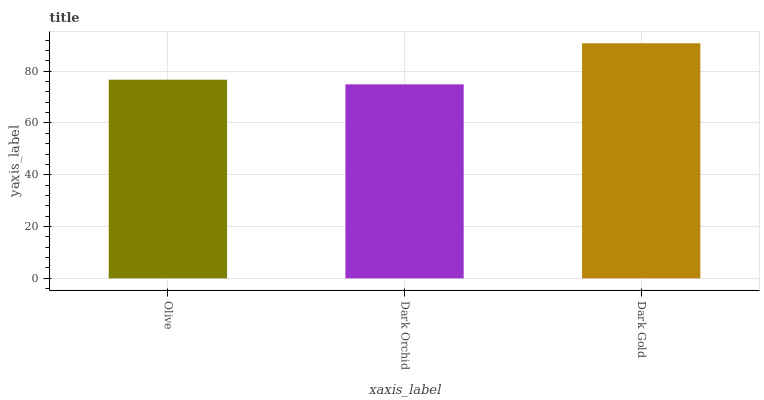Is Dark Orchid the minimum?
Answer yes or no. Yes. Is Dark Gold the maximum?
Answer yes or no. Yes. Is Dark Gold the minimum?
Answer yes or no. No. Is Dark Orchid the maximum?
Answer yes or no. No. Is Dark Gold greater than Dark Orchid?
Answer yes or no. Yes. Is Dark Orchid less than Dark Gold?
Answer yes or no. Yes. Is Dark Orchid greater than Dark Gold?
Answer yes or no. No. Is Dark Gold less than Dark Orchid?
Answer yes or no. No. Is Olive the high median?
Answer yes or no. Yes. Is Olive the low median?
Answer yes or no. Yes. Is Dark Gold the high median?
Answer yes or no. No. Is Dark Gold the low median?
Answer yes or no. No. 